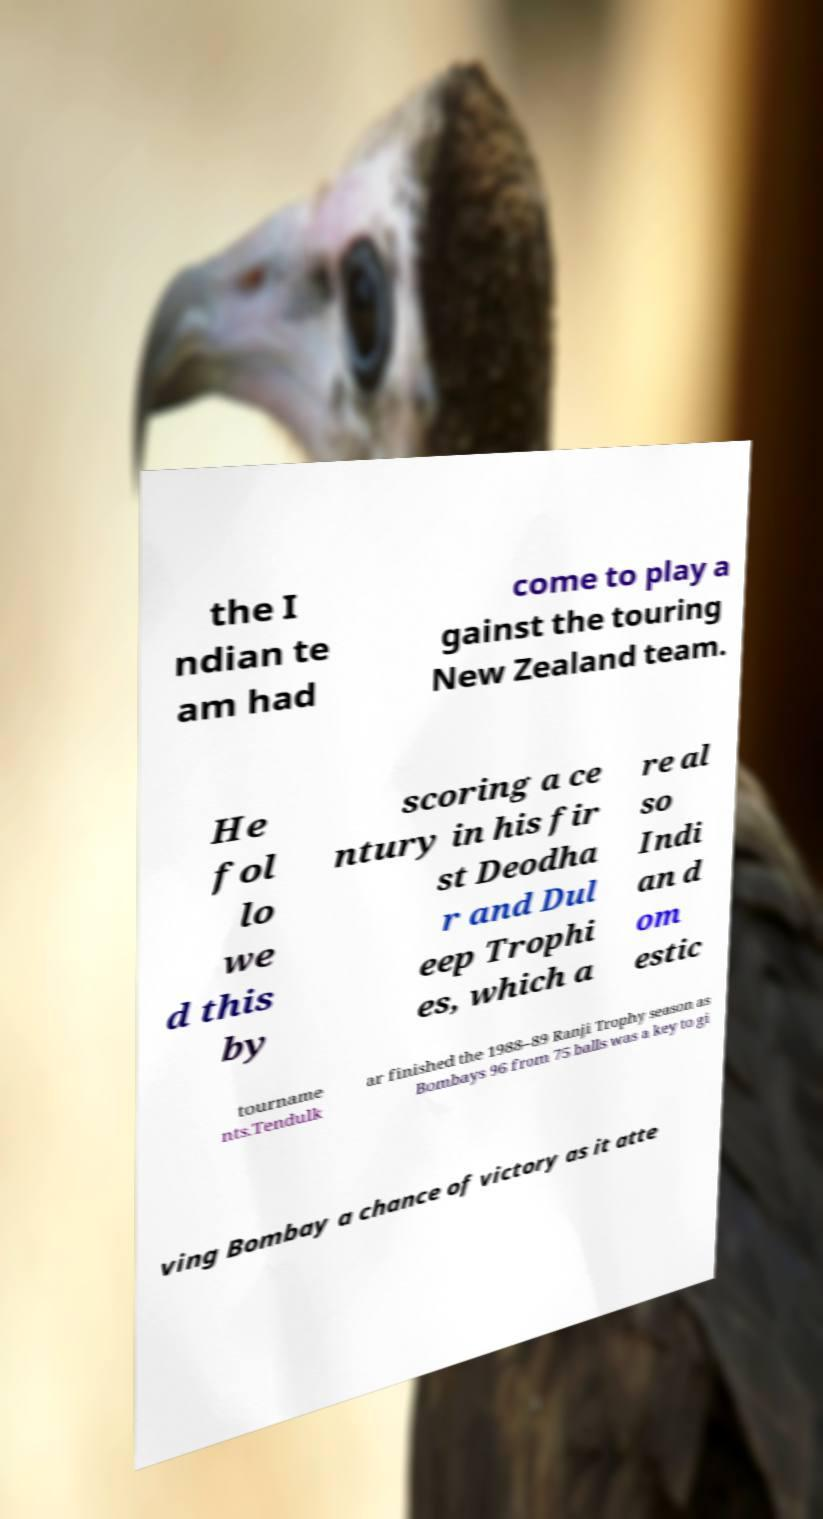There's text embedded in this image that I need extracted. Can you transcribe it verbatim? the I ndian te am had come to play a gainst the touring New Zealand team. He fol lo we d this by scoring a ce ntury in his fir st Deodha r and Dul eep Trophi es, which a re al so Indi an d om estic tourname nts.Tendulk ar finished the 1988–89 Ranji Trophy season as Bombays 96 from 75 balls was a key to gi ving Bombay a chance of victory as it atte 